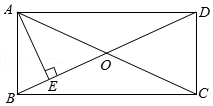Elaborate on what is shown in the illustration. The diagram displays a rectangle with its vertices labeled A, B, C, and D. Diagonals AC and BD intersect at point O. A crucial detail is the perpendicular line AE from vertex A to diagonal BD. This setup suggests potential exploration into the geometric properties, such as the characteristics of diagonals in a rectangle (they bisect each other and are equal in length), the Pythagorean theorem that might be applicable at triangle AED, and interesting symmetrical properties concerning the diagonals and the perpendicular line. 